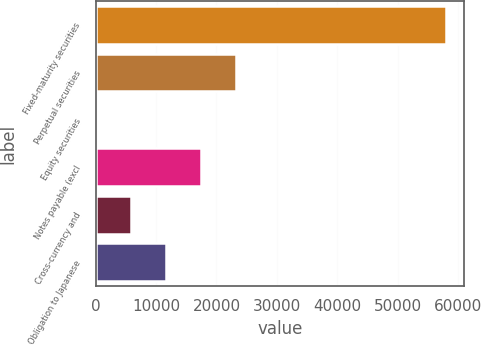<chart> <loc_0><loc_0><loc_500><loc_500><bar_chart><fcel>Fixed-maturity securities<fcel>Perpetual securities<fcel>Equity securities<fcel>Notes payable (excl<fcel>Cross-currency and<fcel>Obligation to Japanese<nl><fcel>58096<fcel>23254.6<fcel>27<fcel>17447.7<fcel>5833.9<fcel>11640.8<nl></chart> 